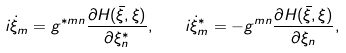<formula> <loc_0><loc_0><loc_500><loc_500>i \dot { \xi } _ { m } = g ^ { \ast m n } \frac { \partial H ( \bar { \xi } , \xi ) } { \partial \xi ^ { * } _ { n } } , \quad i \dot { \xi } ^ { * } _ { m } = - g ^ { m n } \frac { \partial H ( \bar { \xi } , \xi ) } { \partial \xi _ { n } } ,</formula> 